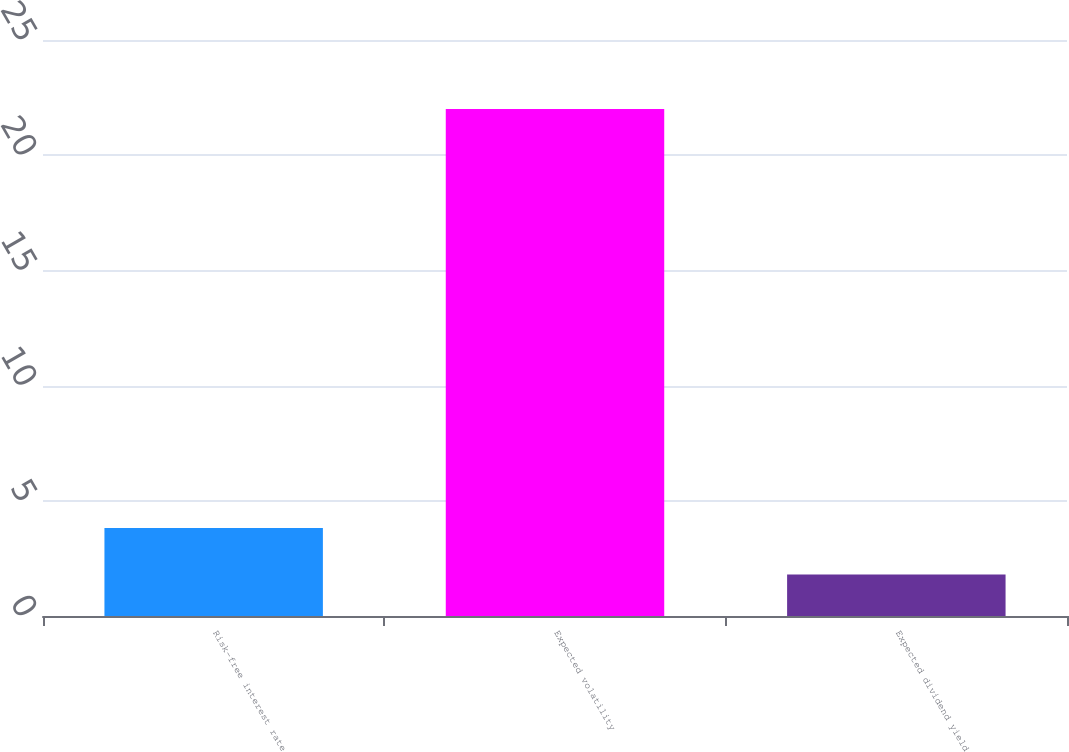Convert chart to OTSL. <chart><loc_0><loc_0><loc_500><loc_500><bar_chart><fcel>Risk-free interest rate<fcel>Expected volatility<fcel>Expected dividend yield<nl><fcel>3.82<fcel>22<fcel>1.8<nl></chart> 